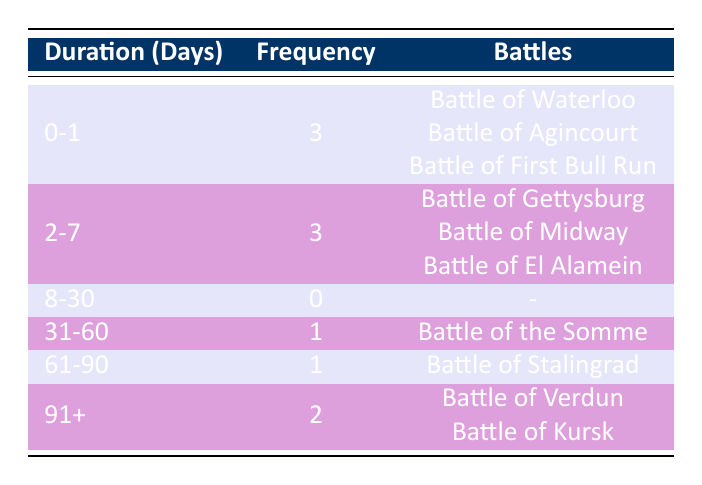What is the frequency of battles that lasted between 0-1 day? Referring to the table, the category for 0-1 day shows a frequency of 3.
Answer: 3 How many battles lasted between 2-7 days? In the table, the frequency for battles lasting from 2-7 days is noted as 3.
Answer: 3 Is the Battle of the Somme included in the duration category of 31-60 days? The table displays that the Battle of the Somme is indeed mentioned in the 31-60 days category, therefore the answer is yes.
Answer: Yes What is the total number of battles that lasted 61 days or more? The table lists 2 battles in the 91+ days category and 1 in the 61-90 days category, so the total is 2 + 1 = 3.
Answer: 3 Are there any battles that lasted between 8-30 days? The table specifically states that there are 0 battles in the 8-30 days duration category.
Answer: No What is the average duration (in days) of battles recorded in the table? First, calculate the total battle durations: (0.5 + 1 + 3 + 2 + 6 + 60 + 76 + 120 + 104) = 373. The total number of battles is 10. Thus, the average duration is 373 / 10 = 37.3 days.
Answer: 37.3 Which duration category has the highest frequency of battles? By examining the table, the 0-1 day and 2-7 day categories both have the highest frequency, tied at 3 battles each.
Answer: 0-1 days and 2-7 days How many battles lasted longer than 60 days? Referring to the table, there are 3 battles listed in the categories that exceed 60 days: the Battle of Stalingrad, the Battle of Verdun, and the Battle of Kursk.
Answer: 3 Is the total number of battles greater than 5? The table lists a total of 10 battles, which confirms that the total number is indeed greater than 5.
Answer: Yes 